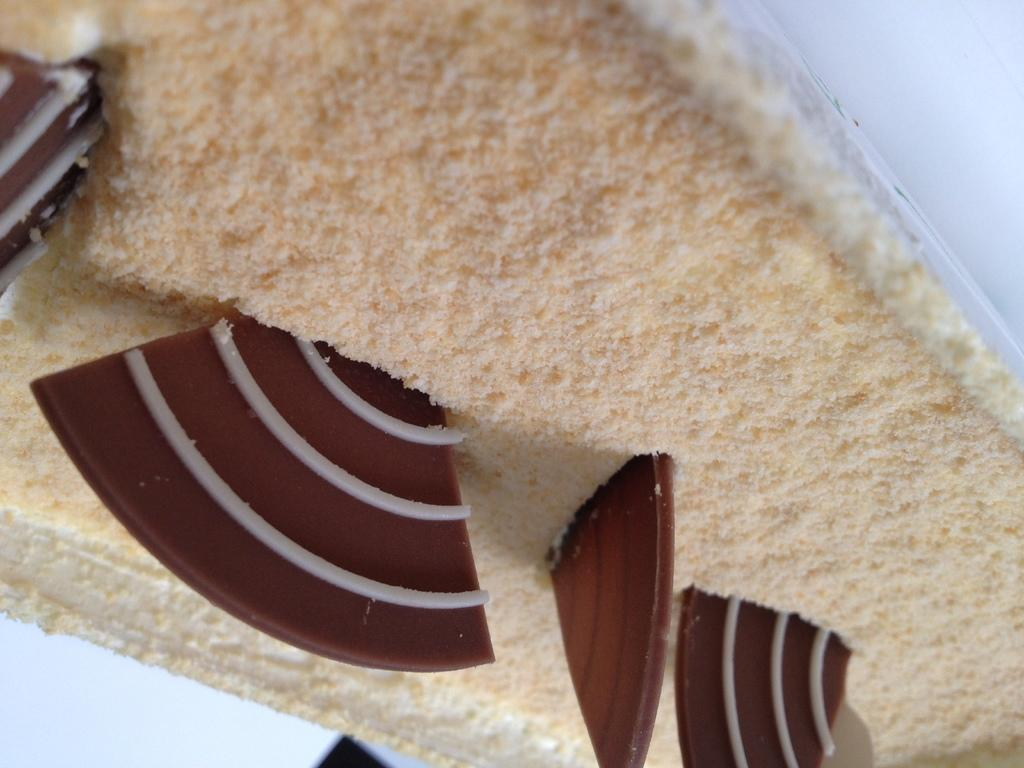What is the main subject of the image? The main subject of the image is food. Where is the food located in the image? The food is in the front of the image. How many spiders can be seen crawling on the flesh in the image? There is no flesh or spiders present in the image; it only features food. 